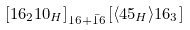Convert formula to latex. <formula><loc_0><loc_0><loc_500><loc_500>\left [ 1 6 _ { 2 } 1 0 _ { H } \right ] _ { 1 6 + \bar { 1 6 } } \left [ \langle 4 5 _ { H } \rangle 1 6 _ { 3 } \right ]</formula> 